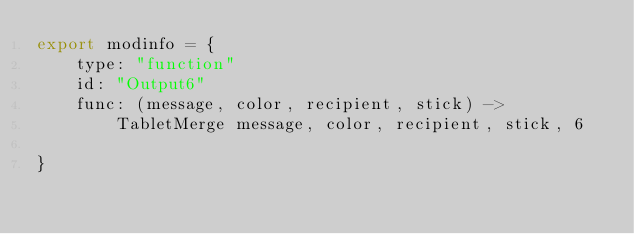<code> <loc_0><loc_0><loc_500><loc_500><_MoonScript_>export modinfo = {
	type: "function"
	id: "Output6"
	func: (message, color, recipient, stick) ->
		TabletMerge message, color, recipient, stick, 6

}
</code> 